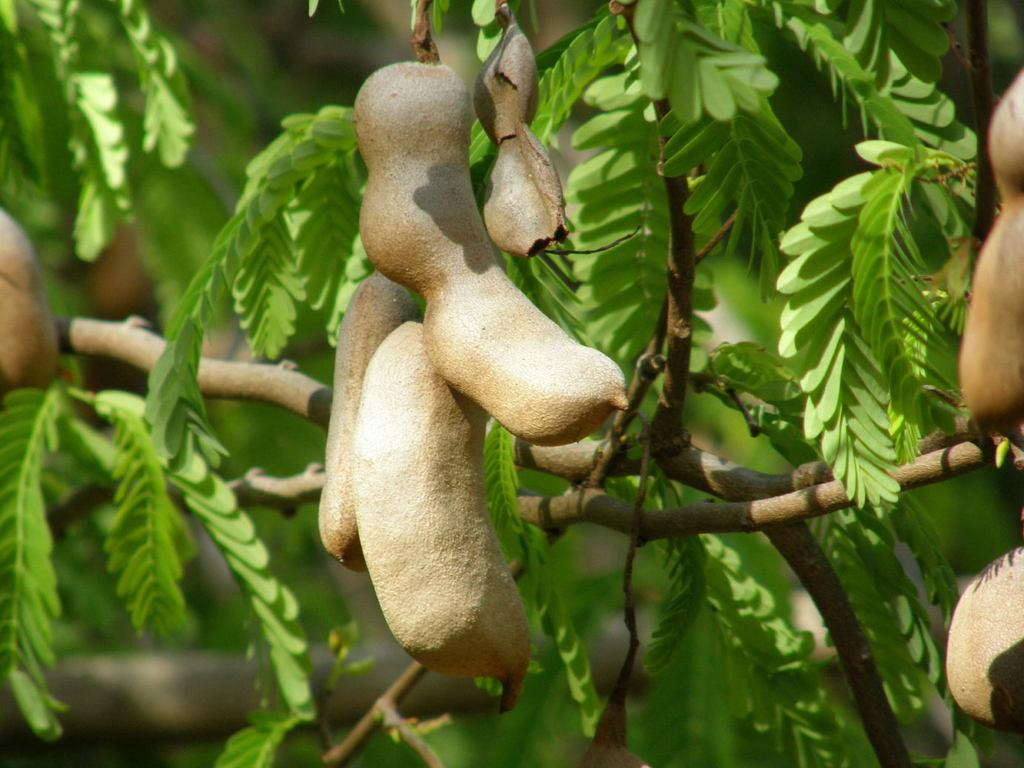What type of tree is in the image? There is a tamarind tree in the image. What is the tamarind tree producing? The tamarind tree has tamarinds. Can you describe the background of the image? The background of the image is blurred. What type of wool is being used to attract the tamarind tree in the image? There is no wool present in the image, and the tamarind tree is not being attracted by any force or material. 